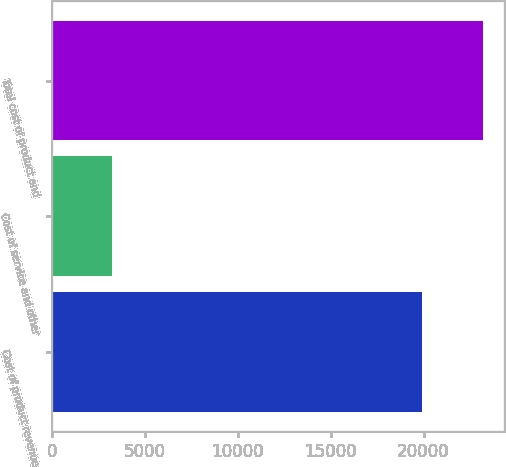Convert chart to OTSL. <chart><loc_0><loc_0><loc_500><loc_500><bar_chart><fcel>Cost of product revenue<fcel>Cost of service and other<fcel>Total cost of product and<nl><fcel>19920<fcel>3261<fcel>23181<nl></chart> 